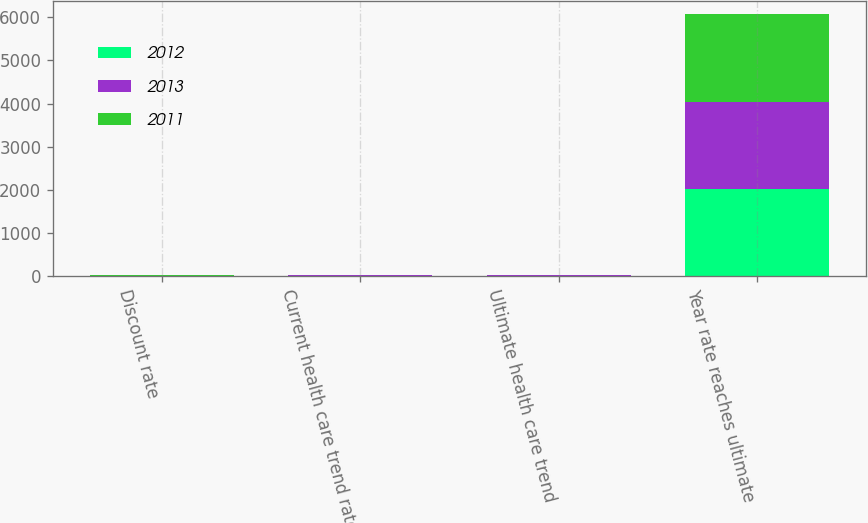<chart> <loc_0><loc_0><loc_500><loc_500><stacked_bar_chart><ecel><fcel>Discount rate<fcel>Current health care trend rate<fcel>Ultimate health care trend<fcel>Year rate reaches ultimate<nl><fcel>2012<fcel>3.45<fcel>8.1<fcel>5<fcel>2023<nl><fcel>2013<fcel>4.6<fcel>8.4<fcel>5<fcel>2023<nl><fcel>2011<fcel>5.75<fcel>8.7<fcel>5<fcel>2023<nl></chart> 